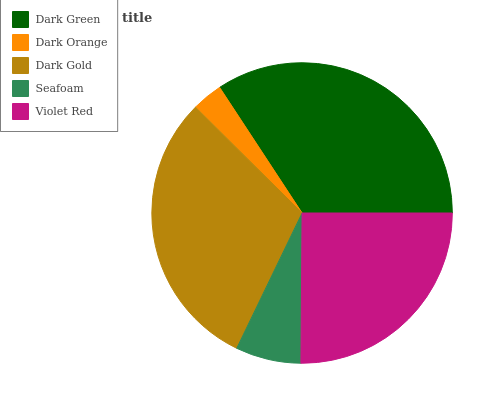Is Dark Orange the minimum?
Answer yes or no. Yes. Is Dark Green the maximum?
Answer yes or no. Yes. Is Dark Gold the minimum?
Answer yes or no. No. Is Dark Gold the maximum?
Answer yes or no. No. Is Dark Gold greater than Dark Orange?
Answer yes or no. Yes. Is Dark Orange less than Dark Gold?
Answer yes or no. Yes. Is Dark Orange greater than Dark Gold?
Answer yes or no. No. Is Dark Gold less than Dark Orange?
Answer yes or no. No. Is Violet Red the high median?
Answer yes or no. Yes. Is Violet Red the low median?
Answer yes or no. Yes. Is Dark Gold the high median?
Answer yes or no. No. Is Dark Gold the low median?
Answer yes or no. No. 